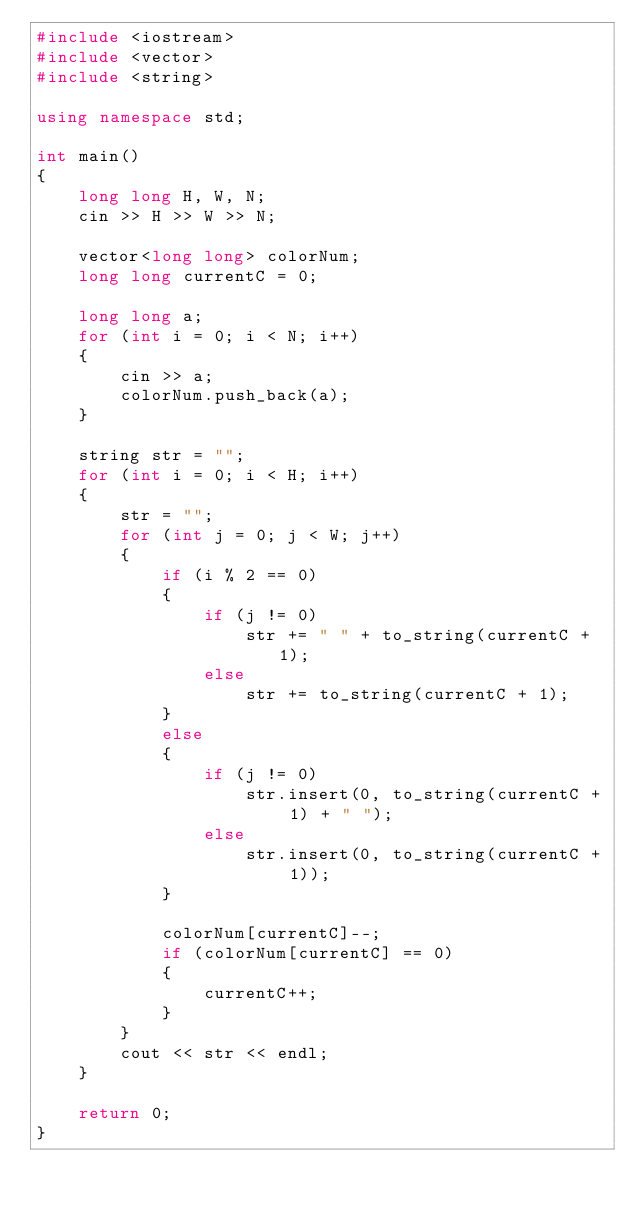<code> <loc_0><loc_0><loc_500><loc_500><_C++_>#include <iostream>
#include <vector>
#include <string>

using namespace std;

int main()
{
    long long H, W, N;
    cin >> H >> W >> N;

    vector<long long> colorNum;
    long long currentC = 0;

    long long a;
    for (int i = 0; i < N; i++)
    {
        cin >> a;
        colorNum.push_back(a);
    }

    string str = "";
    for (int i = 0; i < H; i++)
    {
        str = "";
        for (int j = 0; j < W; j++)
        {
            if (i % 2 == 0)
            {
                if (j != 0)
                    str += " " + to_string(currentC + 1);
                else
                    str += to_string(currentC + 1);
            }
            else
            {
                if (j != 0)
                    str.insert(0, to_string(currentC + 1) + " ");
                else
                    str.insert(0, to_string(currentC + 1));
            }

            colorNum[currentC]--;
            if (colorNum[currentC] == 0)
            {
                currentC++;
            }
        }
        cout << str << endl;
    }

    return 0;
}</code> 